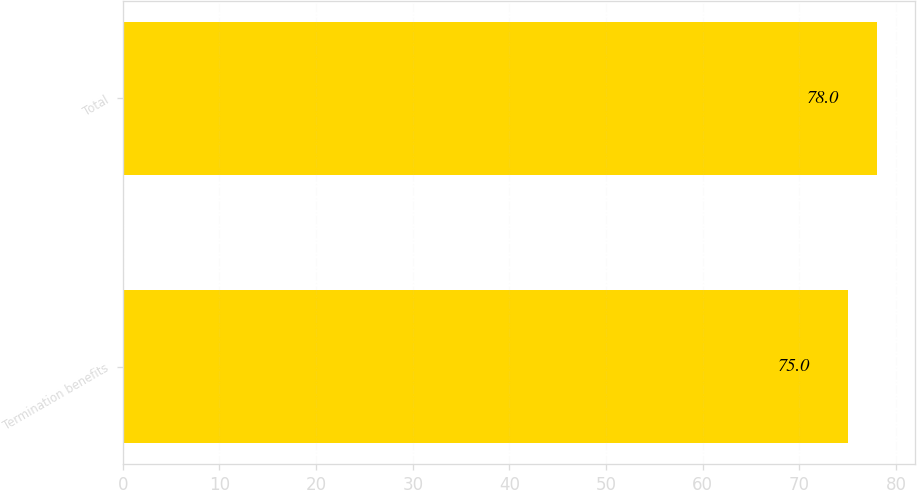<chart> <loc_0><loc_0><loc_500><loc_500><bar_chart><fcel>Termination benefits<fcel>Total<nl><fcel>75<fcel>78<nl></chart> 